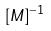<formula> <loc_0><loc_0><loc_500><loc_500>[ M ] ^ { - 1 }</formula> 